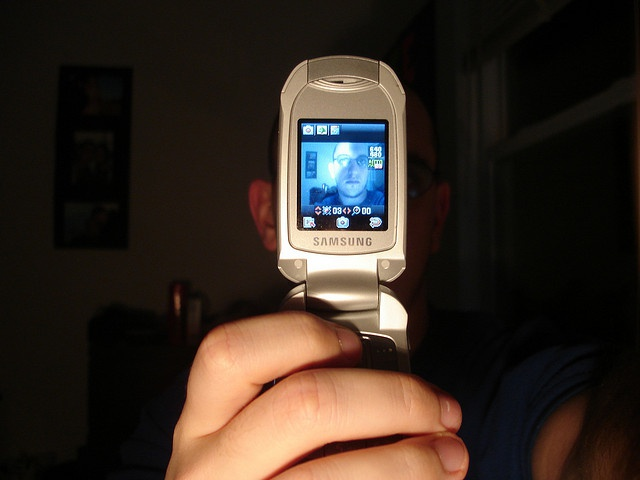Describe the objects in this image and their specific colors. I can see people in black, tan, and maroon tones, cell phone in black, tan, and ivory tones, and people in black, lightblue, white, and blue tones in this image. 